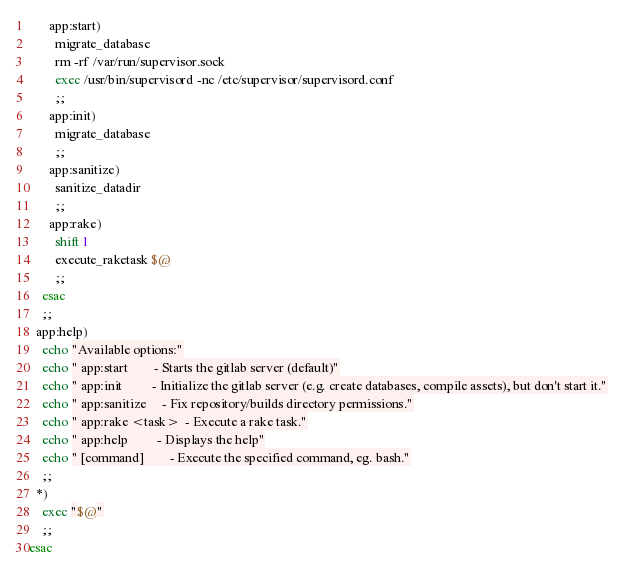Convert code to text. <code><loc_0><loc_0><loc_500><loc_500><_Bash_>      app:start)
        migrate_database
        rm -rf /var/run/supervisor.sock
        exec /usr/bin/supervisord -nc /etc/supervisor/supervisord.conf
        ;;
      app:init)
        migrate_database
        ;;
      app:sanitize)
        sanitize_datadir
        ;;
      app:rake)
        shift 1
        execute_raketask $@
        ;;
    esac
    ;;
  app:help)
    echo "Available options:"
    echo " app:start        - Starts the gitlab server (default)"
    echo " app:init         - Initialize the gitlab server (e.g. create databases, compile assets), but don't start it."
    echo " app:sanitize     - Fix repository/builds directory permissions."
    echo " app:rake <task>  - Execute a rake task."
    echo " app:help         - Displays the help"
    echo " [command]        - Execute the specified command, eg. bash."
    ;;
  *)
    exec "$@"
    ;;
esac
</code> 